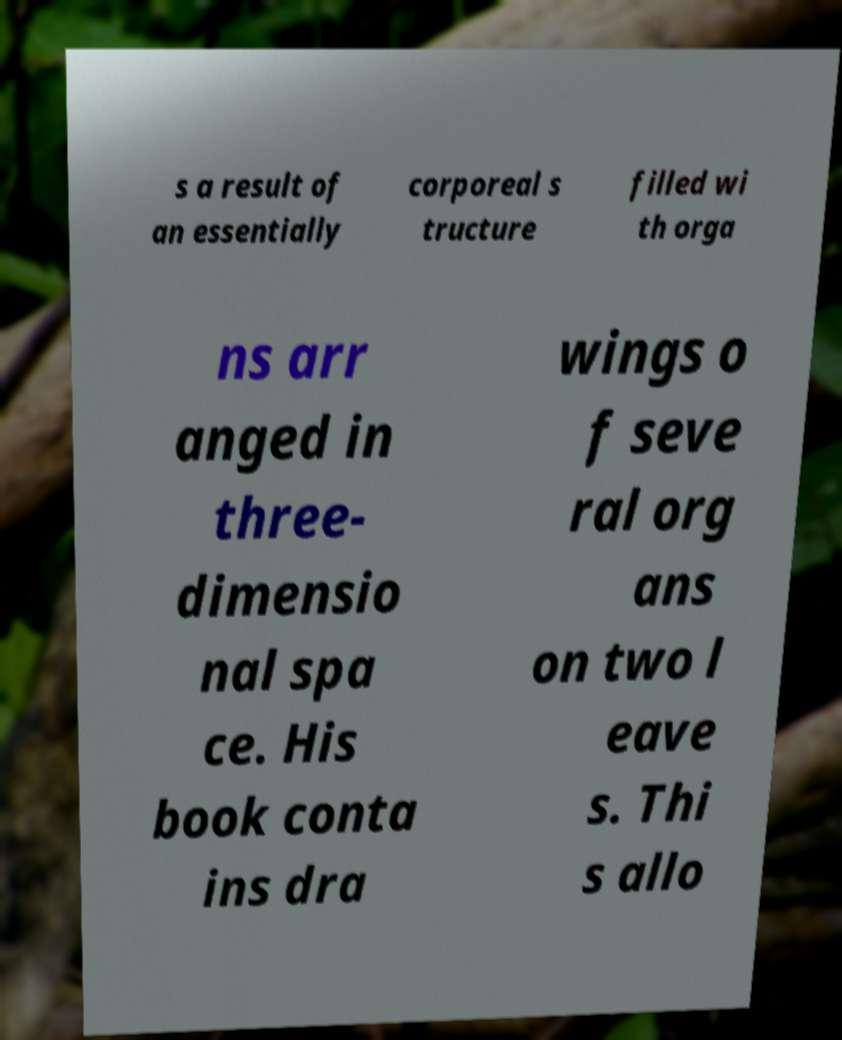For documentation purposes, I need the text within this image transcribed. Could you provide that? s a result of an essentially corporeal s tructure filled wi th orga ns arr anged in three- dimensio nal spa ce. His book conta ins dra wings o f seve ral org ans on two l eave s. Thi s allo 